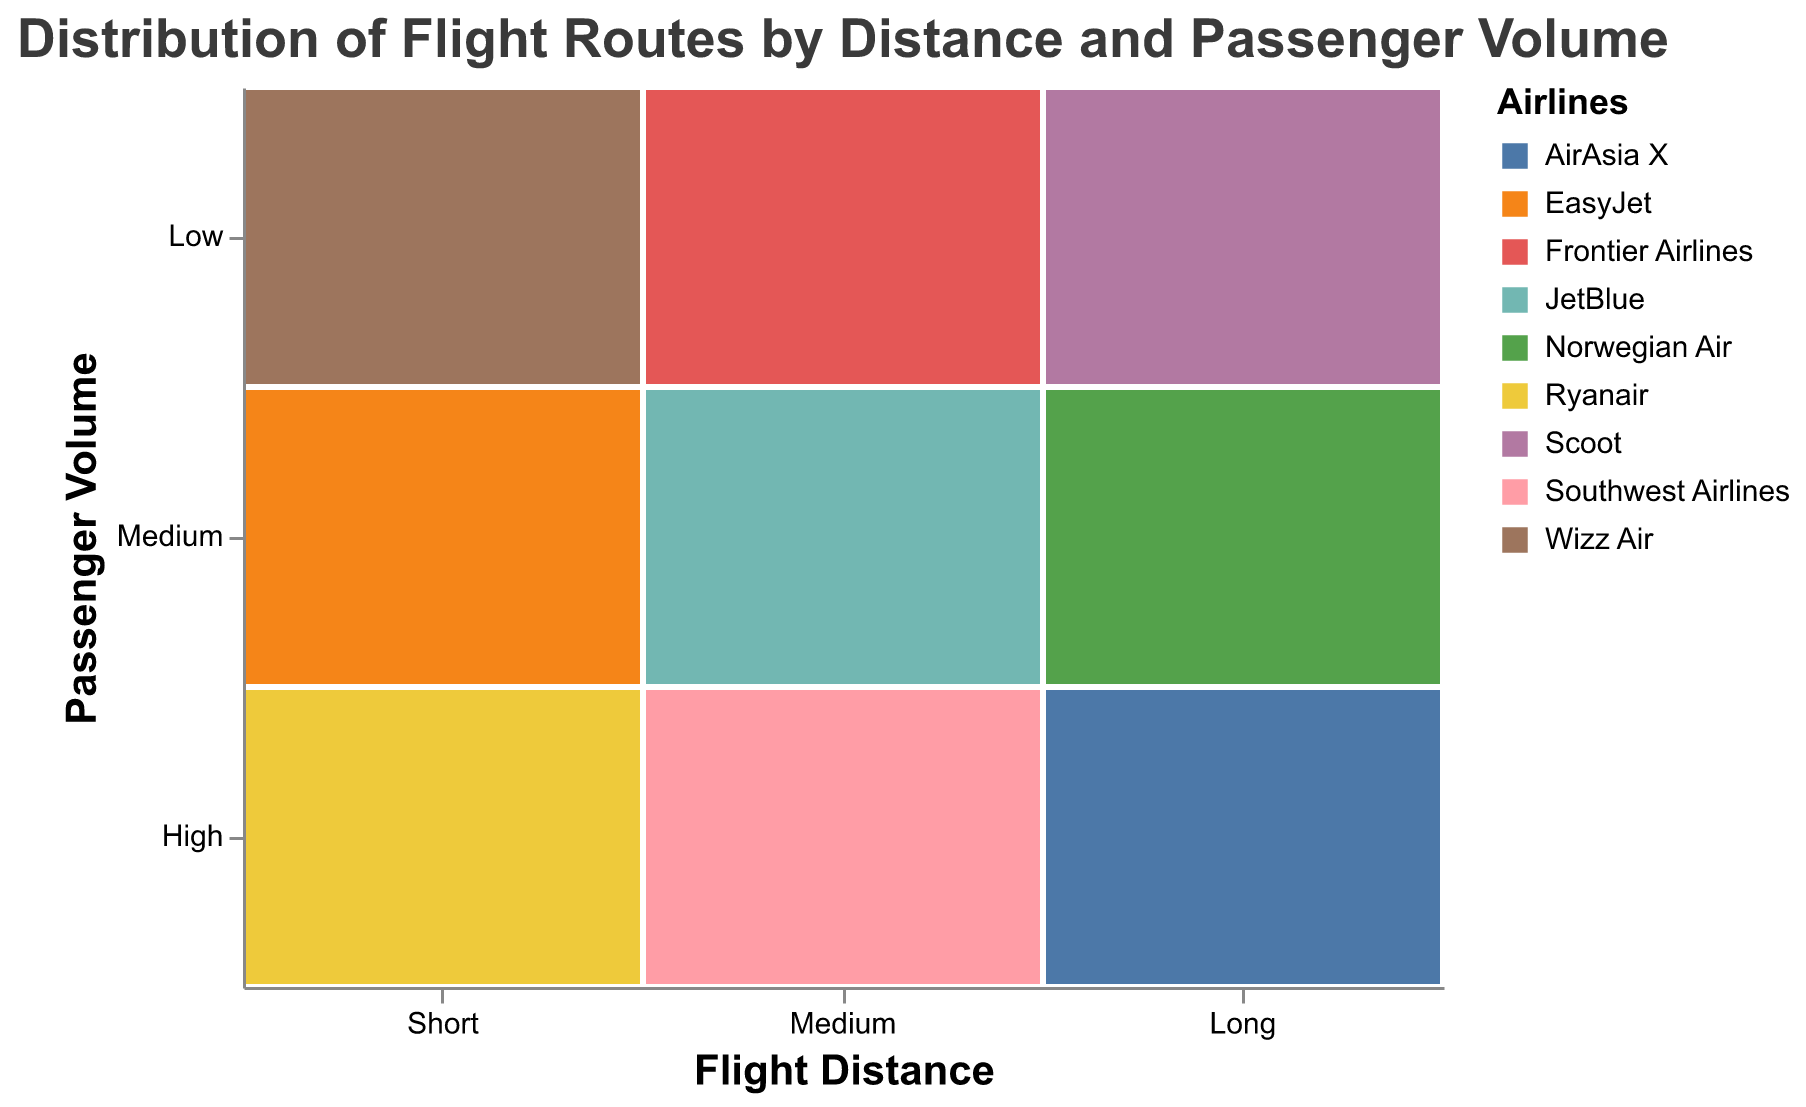What is the title of the figure? The title is usually located at the top of the figure and provides a brief description of what the plot represents.
Answer: Distribution of Flight Routes by Distance and Passenger Volume How many airlines are represented in the figure? Each distinct color in the plot corresponds to a different airline, as indicated by the color legend. By counting the colors in the legend, we can determine the number of airlines.
Answer: 9 What passenger volume category does Ryanair fall into for short-distance flights? Locate Ryanair in the figure and check the corresponding row, which represents the passenger volume category.
Answer: High Which airline has the lowest passenger volume for medium-distance flights? Find the "Medium" column on the x-axis, then look at the "Low" row on the y-axis within that column to identify the airline.
Answer: Frontier Airlines Are there any airlines with high passenger volume for long-distance flights? Examine the "Long" column on the x-axis and check if any rectangle in the "High" row is present.
Answer: Yes, AirAsia X How many airlines operate medium-distance flights with medium passenger volume? Look at the intersection of the "Medium" column and the "Medium" row and count the number of colored rectangles within this cell.
Answer: 1 Which airline operates short-distance flights but has low passenger volume? In the "Short" column on the x-axis, locate the "Low" row on the y-axis to identify the airline.
Answer: Wizz Air What is the relationship between Southwest Airlines and flight distances? Identify Southwest Airlines in the legend and examine where it appears on the x-axis to determine the flight distance category.
Answer: It operates medium-distance flights How does the passenger volume for Norwegian Air vary across different distances? Locate Norwegian Air in the legend and observe its position in the plot across different columns. It is present under "Long" in the "Medium" row.
Answer: Medium for long-distance flights Which airline has the highest passenger volume for each flight distance category (short, medium, long)? For each column (Short, Medium, Long), find the highest row (High) and identify the corresponding airline.
Answer: Ryanair (Short), Southwest Airlines (Medium), AirAsia X (Long) 